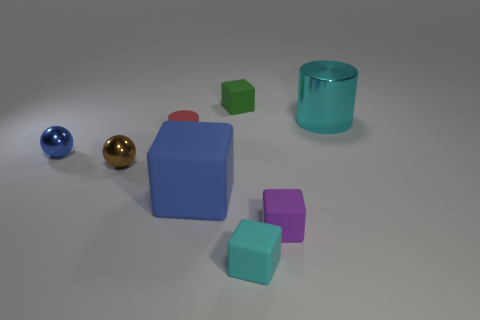Subtract all yellow blocks. Subtract all cyan balls. How many blocks are left? 4 Add 1 small yellow cubes. How many objects exist? 9 Subtract all cylinders. How many objects are left? 6 Add 8 purple matte cubes. How many purple matte cubes exist? 9 Subtract 0 green cylinders. How many objects are left? 8 Subtract all large cyan cylinders. Subtract all small matte cylinders. How many objects are left? 6 Add 8 brown objects. How many brown objects are left? 9 